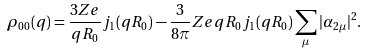Convert formula to latex. <formula><loc_0><loc_0><loc_500><loc_500>\rho _ { 0 0 } ( q ) = \frac { 3 Z e } { q R _ { 0 } } j _ { 1 } ( q R _ { 0 } ) - \frac { 3 } { 8 \pi } Z e q R _ { 0 } j _ { 1 } ( q R _ { 0 } ) \sum _ { \mu } | \alpha _ { 2 \mu } | ^ { 2 } .</formula> 